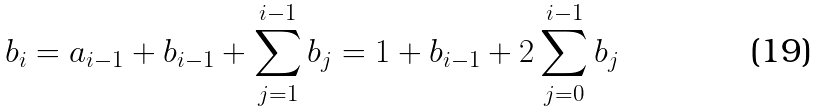<formula> <loc_0><loc_0><loc_500><loc_500>b _ { i } = a _ { i - 1 } + b _ { i - 1 } + \sum _ { j = 1 } ^ { i - 1 } b _ { j } = 1 + b _ { i - 1 } + 2 \sum _ { j = 0 } ^ { i - 1 } b _ { j }</formula> 